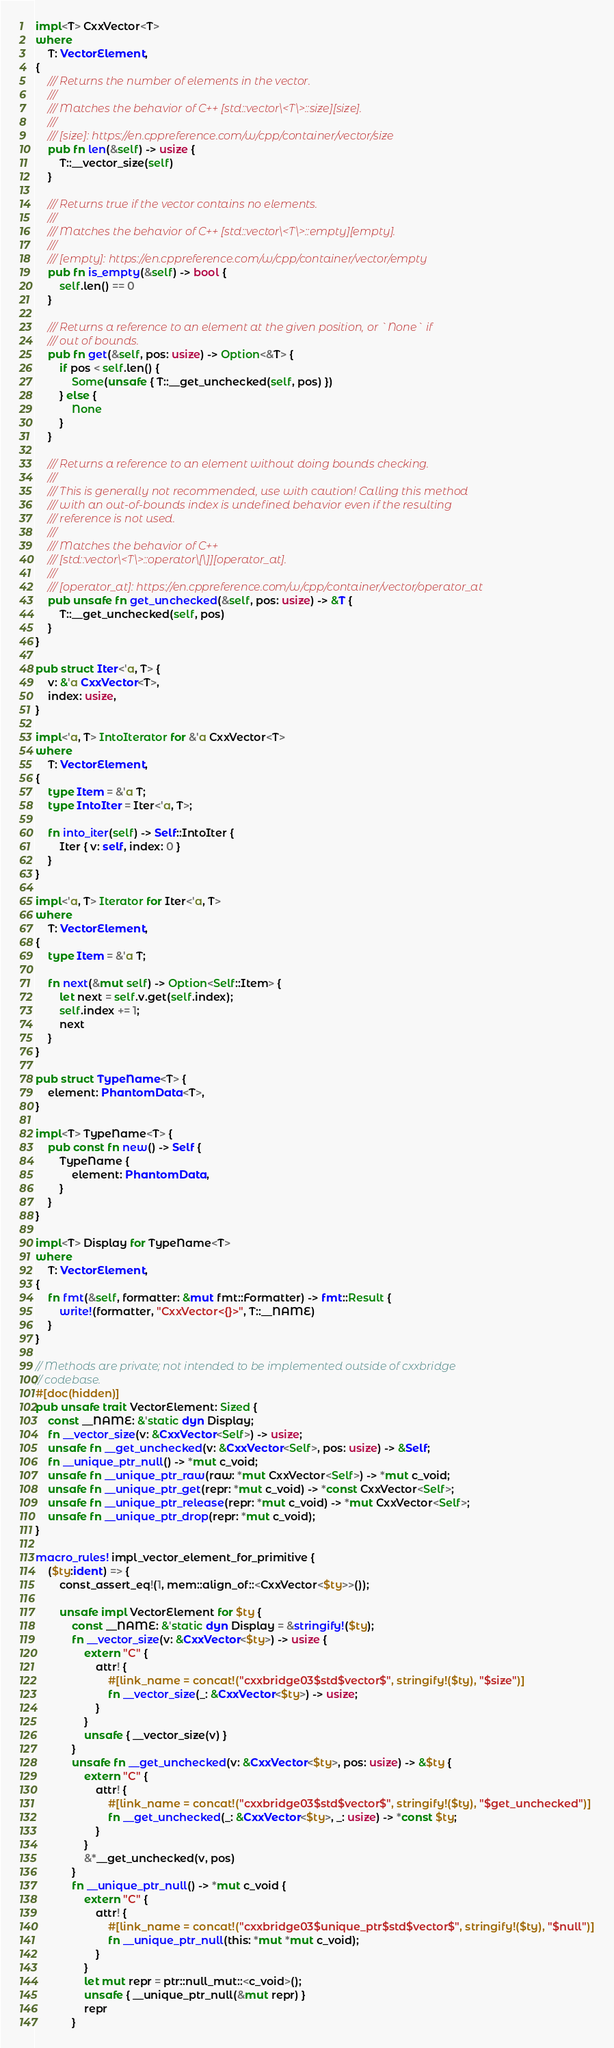Convert code to text. <code><loc_0><loc_0><loc_500><loc_500><_Rust_>
impl<T> CxxVector<T>
where
    T: VectorElement,
{
    /// Returns the number of elements in the vector.
    ///
    /// Matches the behavior of C++ [std::vector\<T\>::size][size].
    ///
    /// [size]: https://en.cppreference.com/w/cpp/container/vector/size
    pub fn len(&self) -> usize {
        T::__vector_size(self)
    }

    /// Returns true if the vector contains no elements.
    ///
    /// Matches the behavior of C++ [std::vector\<T\>::empty][empty].
    ///
    /// [empty]: https://en.cppreference.com/w/cpp/container/vector/empty
    pub fn is_empty(&self) -> bool {
        self.len() == 0
    }

    /// Returns a reference to an element at the given position, or `None` if
    /// out of bounds.
    pub fn get(&self, pos: usize) -> Option<&T> {
        if pos < self.len() {
            Some(unsafe { T::__get_unchecked(self, pos) })
        } else {
            None
        }
    }

    /// Returns a reference to an element without doing bounds checking.
    ///
    /// This is generally not recommended, use with caution! Calling this method
    /// with an out-of-bounds index is undefined behavior even if the resulting
    /// reference is not used.
    ///
    /// Matches the behavior of C++
    /// [std::vector\<T\>::operator\[\]][operator_at].
    ///
    /// [operator_at]: https://en.cppreference.com/w/cpp/container/vector/operator_at
    pub unsafe fn get_unchecked(&self, pos: usize) -> &T {
        T::__get_unchecked(self, pos)
    }
}

pub struct Iter<'a, T> {
    v: &'a CxxVector<T>,
    index: usize,
}

impl<'a, T> IntoIterator for &'a CxxVector<T>
where
    T: VectorElement,
{
    type Item = &'a T;
    type IntoIter = Iter<'a, T>;

    fn into_iter(self) -> Self::IntoIter {
        Iter { v: self, index: 0 }
    }
}

impl<'a, T> Iterator for Iter<'a, T>
where
    T: VectorElement,
{
    type Item = &'a T;

    fn next(&mut self) -> Option<Self::Item> {
        let next = self.v.get(self.index);
        self.index += 1;
        next
    }
}

pub struct TypeName<T> {
    element: PhantomData<T>,
}

impl<T> TypeName<T> {
    pub const fn new() -> Self {
        TypeName {
            element: PhantomData,
        }
    }
}

impl<T> Display for TypeName<T>
where
    T: VectorElement,
{
    fn fmt(&self, formatter: &mut fmt::Formatter) -> fmt::Result {
        write!(formatter, "CxxVector<{}>", T::__NAME)
    }
}

// Methods are private; not intended to be implemented outside of cxxbridge
// codebase.
#[doc(hidden)]
pub unsafe trait VectorElement: Sized {
    const __NAME: &'static dyn Display;
    fn __vector_size(v: &CxxVector<Self>) -> usize;
    unsafe fn __get_unchecked(v: &CxxVector<Self>, pos: usize) -> &Self;
    fn __unique_ptr_null() -> *mut c_void;
    unsafe fn __unique_ptr_raw(raw: *mut CxxVector<Self>) -> *mut c_void;
    unsafe fn __unique_ptr_get(repr: *mut c_void) -> *const CxxVector<Self>;
    unsafe fn __unique_ptr_release(repr: *mut c_void) -> *mut CxxVector<Self>;
    unsafe fn __unique_ptr_drop(repr: *mut c_void);
}

macro_rules! impl_vector_element_for_primitive {
    ($ty:ident) => {
        const_assert_eq!(1, mem::align_of::<CxxVector<$ty>>());

        unsafe impl VectorElement for $ty {
            const __NAME: &'static dyn Display = &stringify!($ty);
            fn __vector_size(v: &CxxVector<$ty>) -> usize {
                extern "C" {
                    attr! {
                        #[link_name = concat!("cxxbridge03$std$vector$", stringify!($ty), "$size")]
                        fn __vector_size(_: &CxxVector<$ty>) -> usize;
                    }
                }
                unsafe { __vector_size(v) }
            }
            unsafe fn __get_unchecked(v: &CxxVector<$ty>, pos: usize) -> &$ty {
                extern "C" {
                    attr! {
                        #[link_name = concat!("cxxbridge03$std$vector$", stringify!($ty), "$get_unchecked")]
                        fn __get_unchecked(_: &CxxVector<$ty>, _: usize) -> *const $ty;
                    }
                }
                &*__get_unchecked(v, pos)
            }
            fn __unique_ptr_null() -> *mut c_void {
                extern "C" {
                    attr! {
                        #[link_name = concat!("cxxbridge03$unique_ptr$std$vector$", stringify!($ty), "$null")]
                        fn __unique_ptr_null(this: *mut *mut c_void);
                    }
                }
                let mut repr = ptr::null_mut::<c_void>();
                unsafe { __unique_ptr_null(&mut repr) }
                repr
            }</code> 